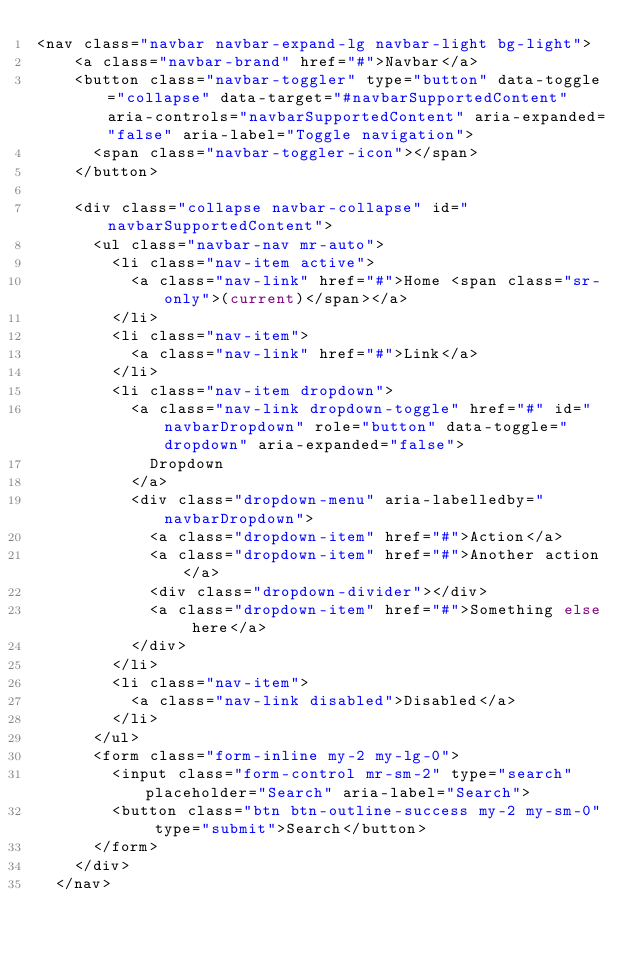Convert code to text. <code><loc_0><loc_0><loc_500><loc_500><_PHP_><nav class="navbar navbar-expand-lg navbar-light bg-light">
    <a class="navbar-brand" href="#">Navbar</a>
    <button class="navbar-toggler" type="button" data-toggle="collapse" data-target="#navbarSupportedContent" aria-controls="navbarSupportedContent" aria-expanded="false" aria-label="Toggle navigation">
      <span class="navbar-toggler-icon"></span>
    </button>

    <div class="collapse navbar-collapse" id="navbarSupportedContent">
      <ul class="navbar-nav mr-auto">
        <li class="nav-item active">
          <a class="nav-link" href="#">Home <span class="sr-only">(current)</span></a>
        </li>
        <li class="nav-item">
          <a class="nav-link" href="#">Link</a>
        </li>
        <li class="nav-item dropdown">
          <a class="nav-link dropdown-toggle" href="#" id="navbarDropdown" role="button" data-toggle="dropdown" aria-expanded="false">
            Dropdown
          </a>
          <div class="dropdown-menu" aria-labelledby="navbarDropdown">
            <a class="dropdown-item" href="#">Action</a>
            <a class="dropdown-item" href="#">Another action</a>
            <div class="dropdown-divider"></div>
            <a class="dropdown-item" href="#">Something else here</a>
          </div>
        </li>
        <li class="nav-item">
          <a class="nav-link disabled">Disabled</a>
        </li>
      </ul>
      <form class="form-inline my-2 my-lg-0">
        <input class="form-control mr-sm-2" type="search" placeholder="Search" aria-label="Search">
        <button class="btn btn-outline-success my-2 my-sm-0" type="submit">Search</button>
      </form>
    </div>
  </nav>
</code> 